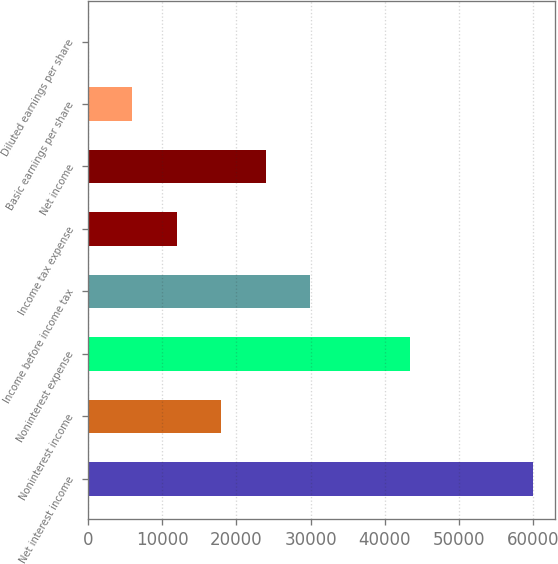Convert chart to OTSL. <chart><loc_0><loc_0><loc_500><loc_500><bar_chart><fcel>Net interest income<fcel>Noninterest income<fcel>Noninterest expense<fcel>Income before income tax<fcel>Income tax expense<fcel>Net income<fcel>Basic earnings per share<fcel>Diluted earnings per share<nl><fcel>59893<fcel>17968.2<fcel>43422<fcel>29946.7<fcel>11978.9<fcel>23957.4<fcel>5989.64<fcel>0.38<nl></chart> 